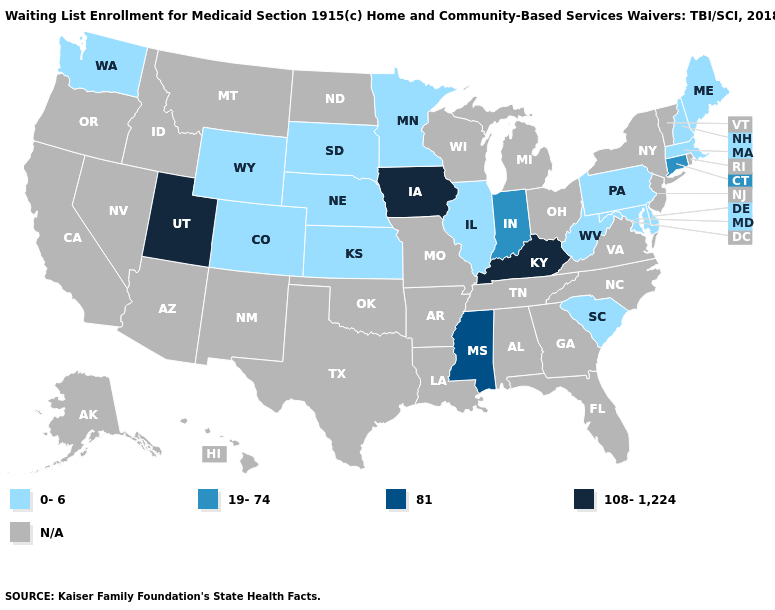How many symbols are there in the legend?
Quick response, please. 5. Among the states that border Tennessee , which have the lowest value?
Quick response, please. Mississippi. What is the value of Michigan?
Be succinct. N/A. Does Kentucky have the highest value in the USA?
Short answer required. Yes. Does South Dakota have the highest value in the USA?
Be succinct. No. Name the states that have a value in the range N/A?
Give a very brief answer. Alabama, Alaska, Arizona, Arkansas, California, Florida, Georgia, Hawaii, Idaho, Louisiana, Michigan, Missouri, Montana, Nevada, New Jersey, New Mexico, New York, North Carolina, North Dakota, Ohio, Oklahoma, Oregon, Rhode Island, Tennessee, Texas, Vermont, Virginia, Wisconsin. Does Wyoming have the lowest value in the USA?
Concise answer only. Yes. Which states have the lowest value in the USA?
Write a very short answer. Colorado, Delaware, Illinois, Kansas, Maine, Maryland, Massachusetts, Minnesota, Nebraska, New Hampshire, Pennsylvania, South Carolina, South Dakota, Washington, West Virginia, Wyoming. Name the states that have a value in the range N/A?
Write a very short answer. Alabama, Alaska, Arizona, Arkansas, California, Florida, Georgia, Hawaii, Idaho, Louisiana, Michigan, Missouri, Montana, Nevada, New Jersey, New Mexico, New York, North Carolina, North Dakota, Ohio, Oklahoma, Oregon, Rhode Island, Tennessee, Texas, Vermont, Virginia, Wisconsin. Name the states that have a value in the range 81?
Give a very brief answer. Mississippi. Does Iowa have the lowest value in the USA?
Give a very brief answer. No. Is the legend a continuous bar?
Quick response, please. No. Does Indiana have the lowest value in the USA?
Quick response, please. No. Does Wyoming have the highest value in the West?
Keep it brief. No. What is the value of Utah?
Short answer required. 108-1,224. 